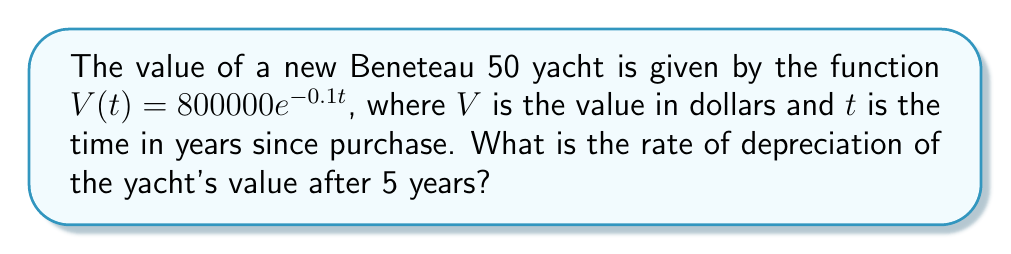Teach me how to tackle this problem. To find the rate of depreciation after 5 years, we need to calculate the derivative of the value function $V(t)$ and evaluate it at $t=5$. Here's how we do it:

1) The given function is $V(t) = 800000e^{-0.1t}$

2) To find the derivative, we use the chain rule:
   $$\frac{dV}{dt} = 800000 \cdot (-0.1) \cdot e^{-0.1t}$$
   $$\frac{dV}{dt} = -80000e^{-0.1t}$$

3) This derivative represents the instantaneous rate of change of the yacht's value at any time $t$.

4) To find the rate of depreciation after 5 years, we evaluate the derivative at $t=5$:
   $$\frac{dV}{dt}\bigg|_{t=5} = -80000e^{-0.1(5)}$$
   $$= -80000e^{-0.5}$$
   $$\approx -48770.67$$

5) The negative sign indicates that the value is decreasing.

Therefore, after 5 years, the yacht's value is depreciating at a rate of approximately $48,770.67 per year.
Answer: $-48770.67 per year 